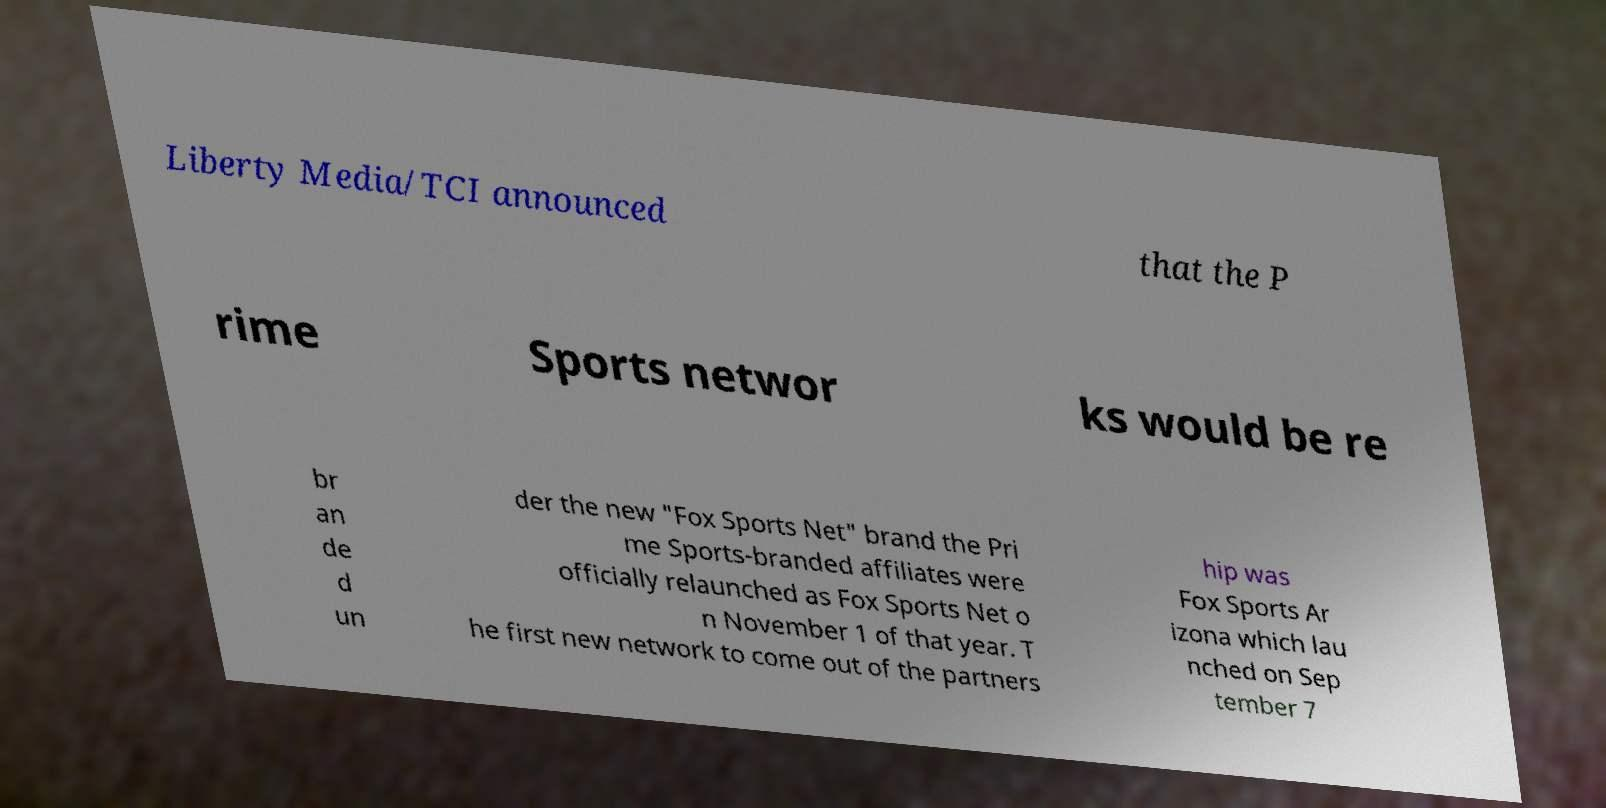Can you read and provide the text displayed in the image?This photo seems to have some interesting text. Can you extract and type it out for me? Liberty Media/TCI announced that the P rime Sports networ ks would be re br an de d un der the new "Fox Sports Net" brand the Pri me Sports-branded affiliates were officially relaunched as Fox Sports Net o n November 1 of that year. T he first new network to come out of the partners hip was Fox Sports Ar izona which lau nched on Sep tember 7 